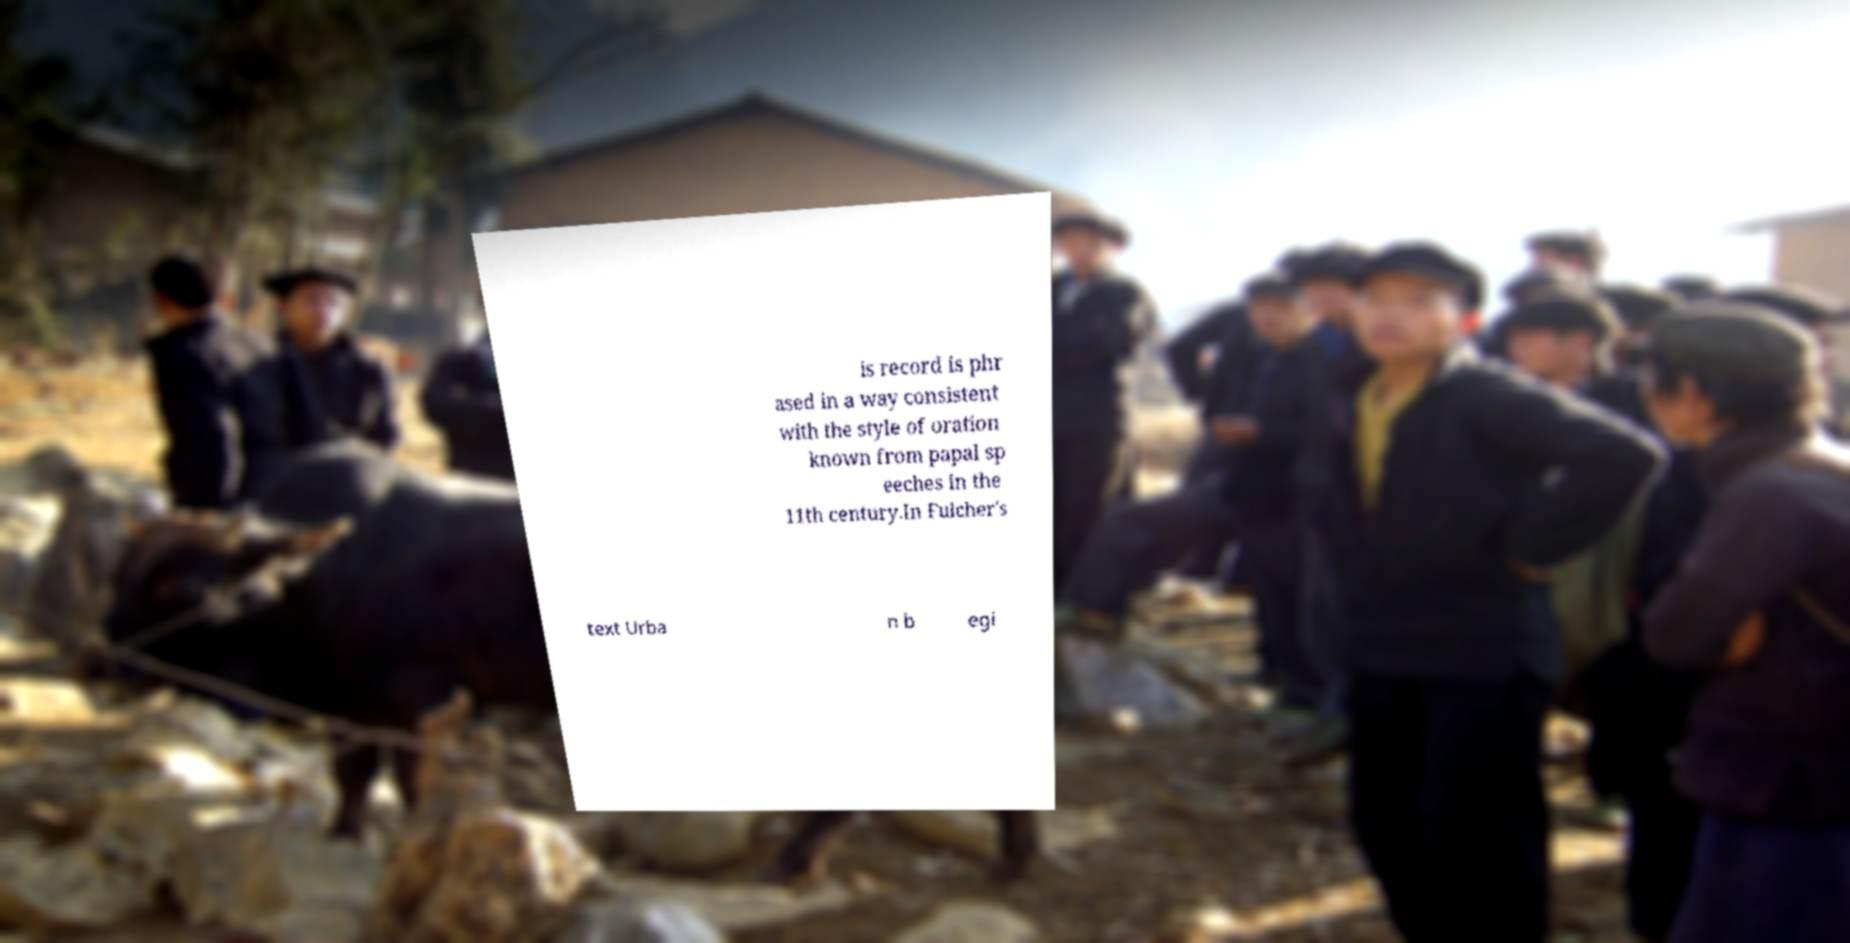Please read and relay the text visible in this image. What does it say? is record is phr ased in a way consistent with the style of oration known from papal sp eeches in the 11th century.In Fulcher's text Urba n b egi 